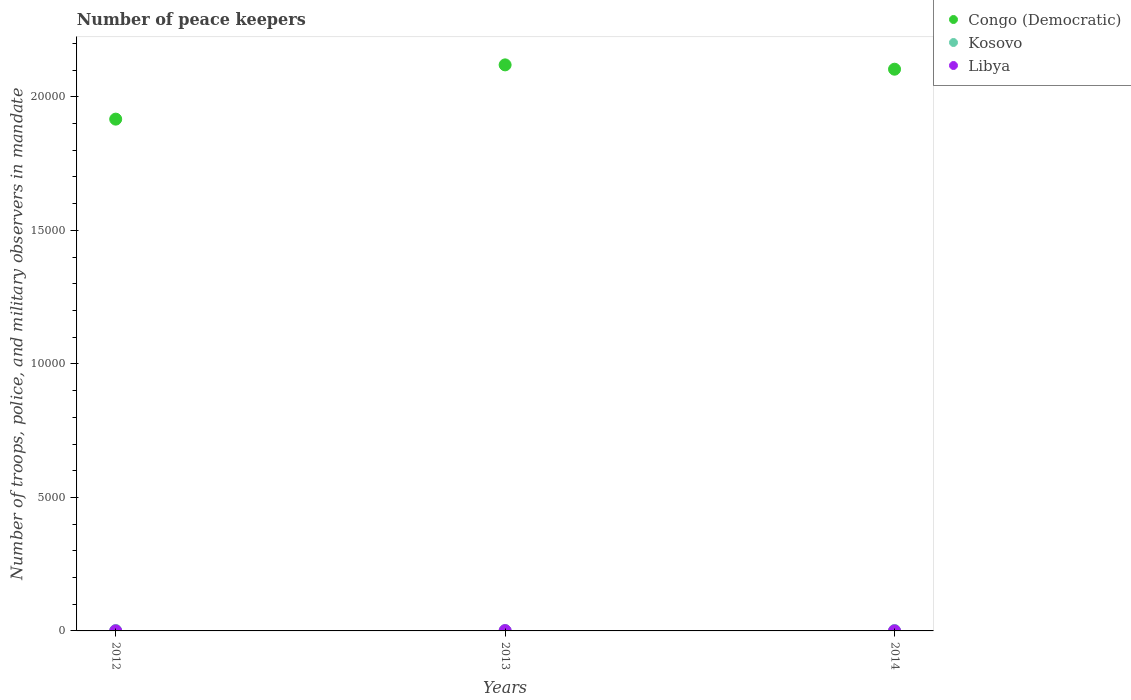What is the number of peace keepers in in Libya in 2012?
Keep it short and to the point. 2. Across all years, what is the maximum number of peace keepers in in Kosovo?
Ensure brevity in your answer.  16. In which year was the number of peace keepers in in Kosovo minimum?
Offer a terse response. 2013. What is the total number of peace keepers in in Congo (Democratic) in the graph?
Ensure brevity in your answer.  6.14e+04. What is the difference between the number of peace keepers in in Libya in 2013 and that in 2014?
Ensure brevity in your answer.  9. What is the average number of peace keepers in in Kosovo per year?
Your answer should be very brief. 15.33. In the year 2012, what is the difference between the number of peace keepers in in Libya and number of peace keepers in in Congo (Democratic)?
Your response must be concise. -1.92e+04. What is the ratio of the number of peace keepers in in Congo (Democratic) in 2012 to that in 2014?
Give a very brief answer. 0.91. Is the number of peace keepers in in Libya in 2012 less than that in 2014?
Your answer should be compact. No. Is the difference between the number of peace keepers in in Libya in 2012 and 2013 greater than the difference between the number of peace keepers in in Congo (Democratic) in 2012 and 2013?
Your response must be concise. Yes. What is the difference between the highest and the second highest number of peace keepers in in Kosovo?
Your response must be concise. 0. Is the sum of the number of peace keepers in in Congo (Democratic) in 2013 and 2014 greater than the maximum number of peace keepers in in Libya across all years?
Offer a terse response. Yes. Does the number of peace keepers in in Libya monotonically increase over the years?
Offer a very short reply. No. Is the number of peace keepers in in Kosovo strictly greater than the number of peace keepers in in Libya over the years?
Your answer should be very brief. Yes. How many dotlines are there?
Keep it short and to the point. 3. How many years are there in the graph?
Offer a very short reply. 3. Are the values on the major ticks of Y-axis written in scientific E-notation?
Make the answer very short. No. Does the graph contain any zero values?
Provide a succinct answer. No. Does the graph contain grids?
Your response must be concise. No. Where does the legend appear in the graph?
Your response must be concise. Top right. How are the legend labels stacked?
Ensure brevity in your answer.  Vertical. What is the title of the graph?
Your answer should be very brief. Number of peace keepers. What is the label or title of the X-axis?
Offer a very short reply. Years. What is the label or title of the Y-axis?
Your answer should be compact. Number of troops, police, and military observers in mandate. What is the Number of troops, police, and military observers in mandate in Congo (Democratic) in 2012?
Your answer should be compact. 1.92e+04. What is the Number of troops, police, and military observers in mandate of Congo (Democratic) in 2013?
Your answer should be compact. 2.12e+04. What is the Number of troops, police, and military observers in mandate in Libya in 2013?
Offer a terse response. 11. What is the Number of troops, police, and military observers in mandate in Congo (Democratic) in 2014?
Provide a short and direct response. 2.10e+04. Across all years, what is the maximum Number of troops, police, and military observers in mandate of Congo (Democratic)?
Offer a terse response. 2.12e+04. Across all years, what is the minimum Number of troops, police, and military observers in mandate in Congo (Democratic)?
Give a very brief answer. 1.92e+04. What is the total Number of troops, police, and military observers in mandate of Congo (Democratic) in the graph?
Offer a terse response. 6.14e+04. What is the total Number of troops, police, and military observers in mandate in Kosovo in the graph?
Ensure brevity in your answer.  46. What is the total Number of troops, police, and military observers in mandate of Libya in the graph?
Your response must be concise. 15. What is the difference between the Number of troops, police, and military observers in mandate in Congo (Democratic) in 2012 and that in 2013?
Offer a very short reply. -2032. What is the difference between the Number of troops, police, and military observers in mandate of Congo (Democratic) in 2012 and that in 2014?
Keep it short and to the point. -1870. What is the difference between the Number of troops, police, and military observers in mandate in Kosovo in 2012 and that in 2014?
Make the answer very short. 0. What is the difference between the Number of troops, police, and military observers in mandate in Libya in 2012 and that in 2014?
Your answer should be compact. 0. What is the difference between the Number of troops, police, and military observers in mandate of Congo (Democratic) in 2013 and that in 2014?
Provide a short and direct response. 162. What is the difference between the Number of troops, police, and military observers in mandate in Kosovo in 2013 and that in 2014?
Provide a short and direct response. -2. What is the difference between the Number of troops, police, and military observers in mandate of Congo (Democratic) in 2012 and the Number of troops, police, and military observers in mandate of Kosovo in 2013?
Keep it short and to the point. 1.92e+04. What is the difference between the Number of troops, police, and military observers in mandate in Congo (Democratic) in 2012 and the Number of troops, police, and military observers in mandate in Libya in 2013?
Your response must be concise. 1.92e+04. What is the difference between the Number of troops, police, and military observers in mandate of Kosovo in 2012 and the Number of troops, police, and military observers in mandate of Libya in 2013?
Ensure brevity in your answer.  5. What is the difference between the Number of troops, police, and military observers in mandate of Congo (Democratic) in 2012 and the Number of troops, police, and military observers in mandate of Kosovo in 2014?
Make the answer very short. 1.92e+04. What is the difference between the Number of troops, police, and military observers in mandate of Congo (Democratic) in 2012 and the Number of troops, police, and military observers in mandate of Libya in 2014?
Your response must be concise. 1.92e+04. What is the difference between the Number of troops, police, and military observers in mandate in Congo (Democratic) in 2013 and the Number of troops, police, and military observers in mandate in Kosovo in 2014?
Your answer should be compact. 2.12e+04. What is the difference between the Number of troops, police, and military observers in mandate of Congo (Democratic) in 2013 and the Number of troops, police, and military observers in mandate of Libya in 2014?
Give a very brief answer. 2.12e+04. What is the difference between the Number of troops, police, and military observers in mandate in Kosovo in 2013 and the Number of troops, police, and military observers in mandate in Libya in 2014?
Provide a short and direct response. 12. What is the average Number of troops, police, and military observers in mandate of Congo (Democratic) per year?
Give a very brief answer. 2.05e+04. What is the average Number of troops, police, and military observers in mandate in Kosovo per year?
Your answer should be very brief. 15.33. In the year 2012, what is the difference between the Number of troops, police, and military observers in mandate in Congo (Democratic) and Number of troops, police, and military observers in mandate in Kosovo?
Your answer should be very brief. 1.92e+04. In the year 2012, what is the difference between the Number of troops, police, and military observers in mandate in Congo (Democratic) and Number of troops, police, and military observers in mandate in Libya?
Keep it short and to the point. 1.92e+04. In the year 2013, what is the difference between the Number of troops, police, and military observers in mandate of Congo (Democratic) and Number of troops, police, and military observers in mandate of Kosovo?
Provide a short and direct response. 2.12e+04. In the year 2013, what is the difference between the Number of troops, police, and military observers in mandate of Congo (Democratic) and Number of troops, police, and military observers in mandate of Libya?
Keep it short and to the point. 2.12e+04. In the year 2013, what is the difference between the Number of troops, police, and military observers in mandate in Kosovo and Number of troops, police, and military observers in mandate in Libya?
Offer a terse response. 3. In the year 2014, what is the difference between the Number of troops, police, and military observers in mandate of Congo (Democratic) and Number of troops, police, and military observers in mandate of Kosovo?
Provide a succinct answer. 2.10e+04. In the year 2014, what is the difference between the Number of troops, police, and military observers in mandate of Congo (Democratic) and Number of troops, police, and military observers in mandate of Libya?
Provide a succinct answer. 2.10e+04. What is the ratio of the Number of troops, police, and military observers in mandate in Congo (Democratic) in 2012 to that in 2013?
Provide a succinct answer. 0.9. What is the ratio of the Number of troops, police, and military observers in mandate of Libya in 2012 to that in 2013?
Offer a terse response. 0.18. What is the ratio of the Number of troops, police, and military observers in mandate of Congo (Democratic) in 2012 to that in 2014?
Your answer should be very brief. 0.91. What is the ratio of the Number of troops, police, and military observers in mandate in Congo (Democratic) in 2013 to that in 2014?
Provide a succinct answer. 1.01. What is the difference between the highest and the second highest Number of troops, police, and military observers in mandate of Congo (Democratic)?
Your answer should be very brief. 162. What is the difference between the highest and the second highest Number of troops, police, and military observers in mandate of Kosovo?
Provide a succinct answer. 0. What is the difference between the highest and the lowest Number of troops, police, and military observers in mandate in Congo (Democratic)?
Your answer should be very brief. 2032. What is the difference between the highest and the lowest Number of troops, police, and military observers in mandate of Kosovo?
Ensure brevity in your answer.  2. What is the difference between the highest and the lowest Number of troops, police, and military observers in mandate of Libya?
Your response must be concise. 9. 